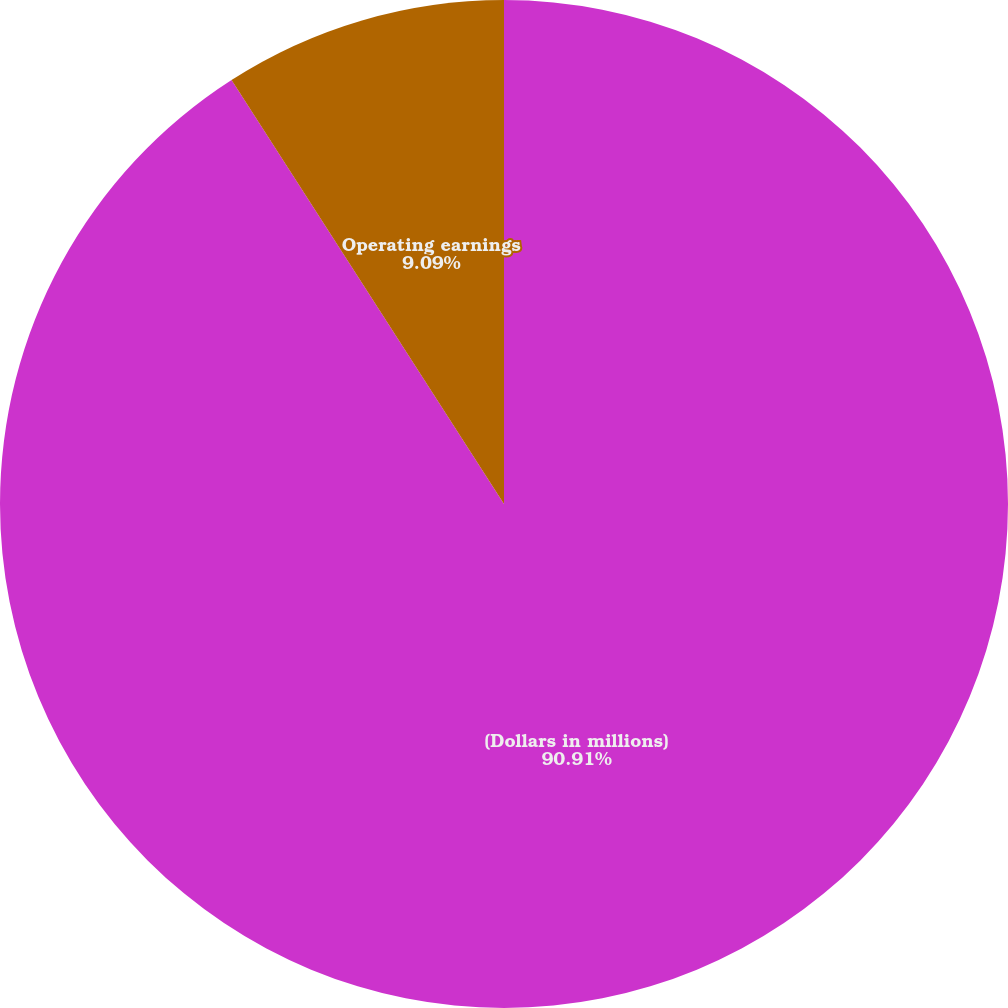<chart> <loc_0><loc_0><loc_500><loc_500><pie_chart><fcel>(Dollars in millions)<fcel>Segment net sales<fcel>Operating earnings<nl><fcel>90.91%<fcel>0.0%<fcel>9.09%<nl></chart> 